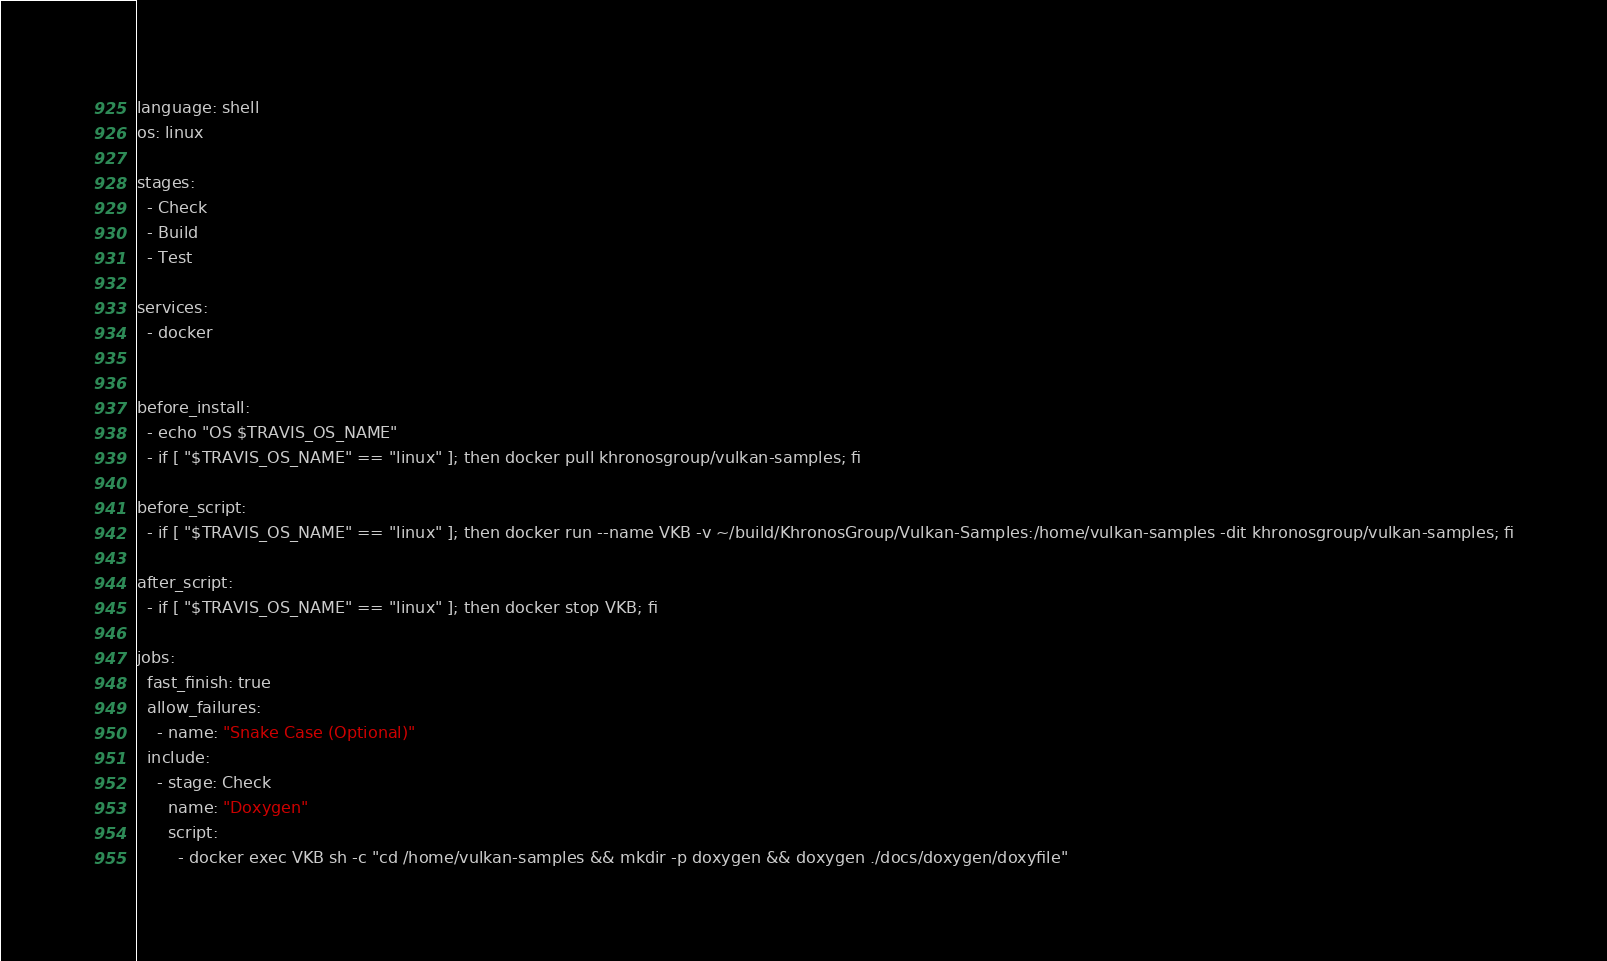Convert code to text. <code><loc_0><loc_0><loc_500><loc_500><_YAML_>language: shell
os: linux

stages:
  - Check
  - Build
  - Test

services:
  - docker


before_install:
  - echo "OS $TRAVIS_OS_NAME"
  - if [ "$TRAVIS_OS_NAME" == "linux" ]; then docker pull khronosgroup/vulkan-samples; fi

before_script:
  - if [ "$TRAVIS_OS_NAME" == "linux" ]; then docker run --name VKB -v ~/build/KhronosGroup/Vulkan-Samples:/home/vulkan-samples -dit khronosgroup/vulkan-samples; fi

after_script:
  - if [ "$TRAVIS_OS_NAME" == "linux" ]; then docker stop VKB; fi

jobs:
  fast_finish: true
  allow_failures:
    - name: "Snake Case (Optional)"
  include:
    - stage: Check
      name: "Doxygen"
      script: 
        - docker exec VKB sh -c "cd /home/vulkan-samples && mkdir -p doxygen && doxygen ./docs/doxygen/doxyfile"</code> 